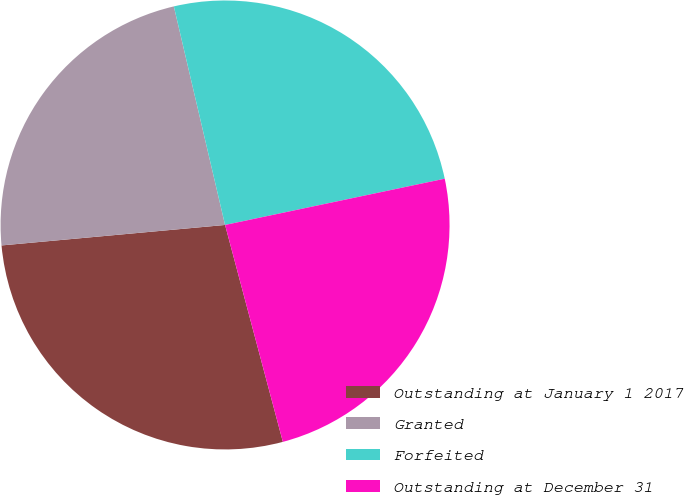Convert chart. <chart><loc_0><loc_0><loc_500><loc_500><pie_chart><fcel>Outstanding at January 1 2017<fcel>Granted<fcel>Forfeited<fcel>Outstanding at December 31<nl><fcel>27.69%<fcel>22.79%<fcel>25.36%<fcel>24.16%<nl></chart> 